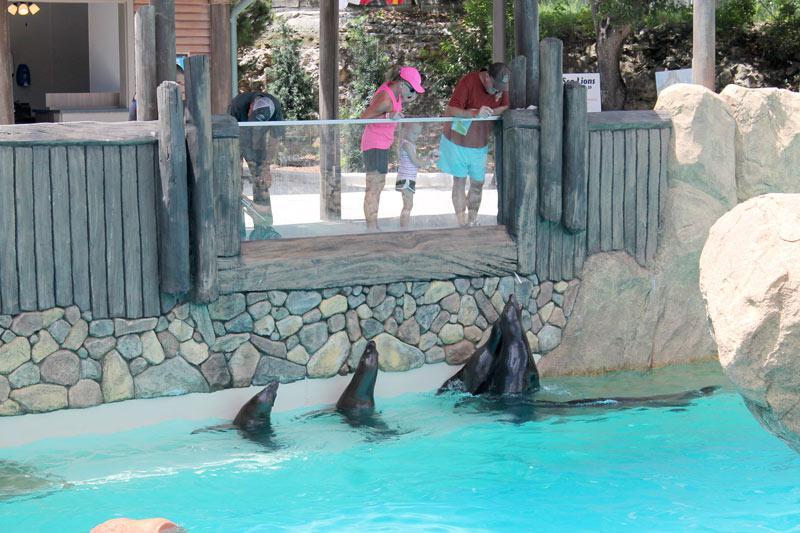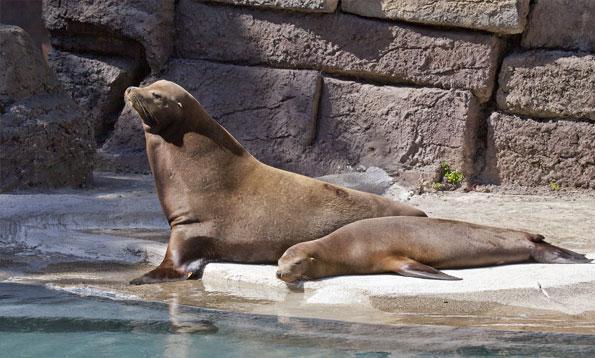The first image is the image on the left, the second image is the image on the right. Analyze the images presented: Is the assertion "An image includes one reclining seal next to a seal with raised head and shoulders." valid? Answer yes or no. Yes. The first image is the image on the left, the second image is the image on the right. Evaluate the accuracy of this statement regarding the images: "At least one of the seals is in the water.". Is it true? Answer yes or no. Yes. 